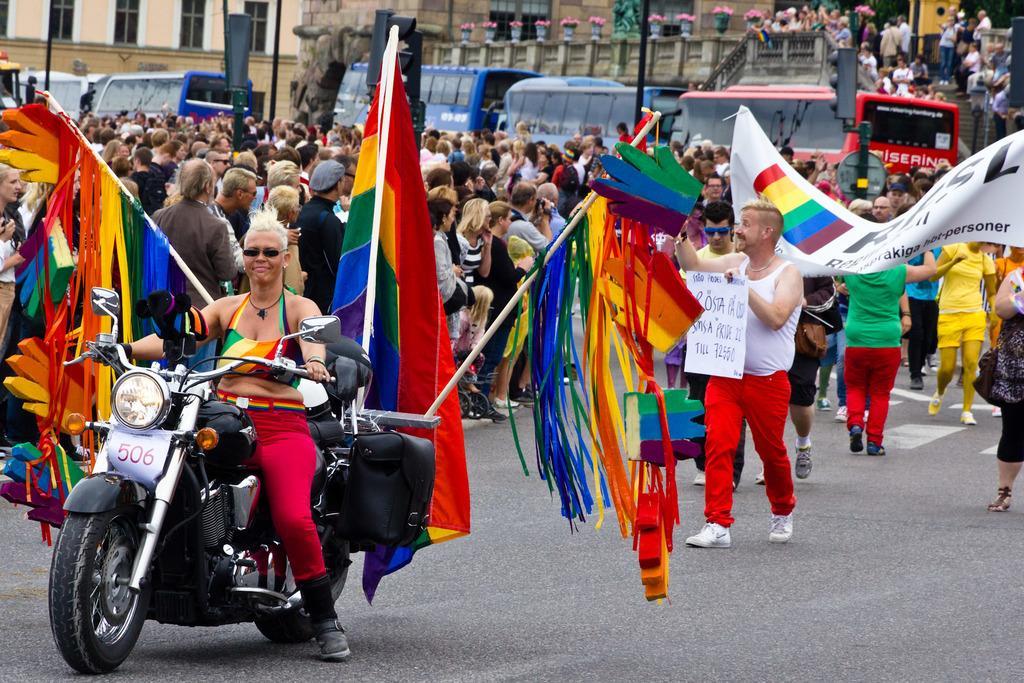Could you give a brief overview of what you see in this image? This picture describes about group of people, they are all standing, and few are walking, and a person is riding a motorcycle on the road, in the background we can see few people are holding a flex in their hands, and also we can see couple of buses, buildings in the background. 